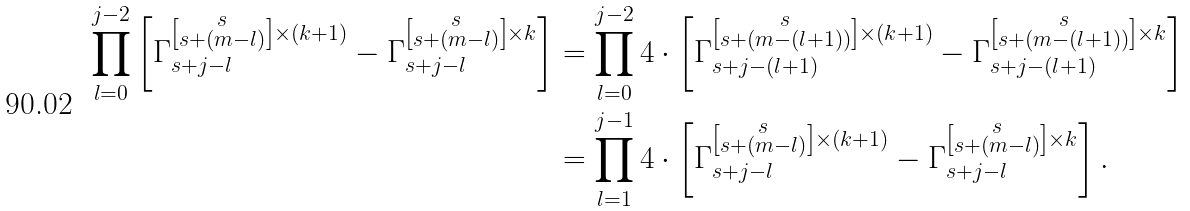<formula> <loc_0><loc_0><loc_500><loc_500>\prod _ { l = 0 } ^ { j - 2 } \left [ \Gamma _ { s + j - l } ^ { \left [ \substack { s \\ s + ( m - l ) } \right ] \times ( k + 1 ) } - \Gamma _ { s + j - l } ^ { \left [ \substack { s \\ s + ( m - l ) } \right ] \times k } \right ] & = \prod _ { l = 0 } ^ { j - 2 } 4 \cdot \left [ \Gamma _ { s + j - ( l + 1 ) } ^ { \left [ \substack { s \\ s + ( m - ( l + 1 ) ) } \right ] \times ( k + 1 ) } - \Gamma _ { s + j - ( l + 1 ) } ^ { \left [ \substack { s \\ s + ( m - ( l + 1 ) ) } \right ] \times k } \right ] \\ & = \prod _ { l = 1 } ^ { j - 1 } 4 \cdot \left [ \Gamma _ { s + j - l } ^ { \left [ \substack { s \\ s + ( m - l ) } \right ] \times ( k + 1 ) } - \Gamma _ { s + j - l } ^ { \left [ \substack { s \\ s + ( m - l ) } \right ] \times k } \right ] .</formula> 